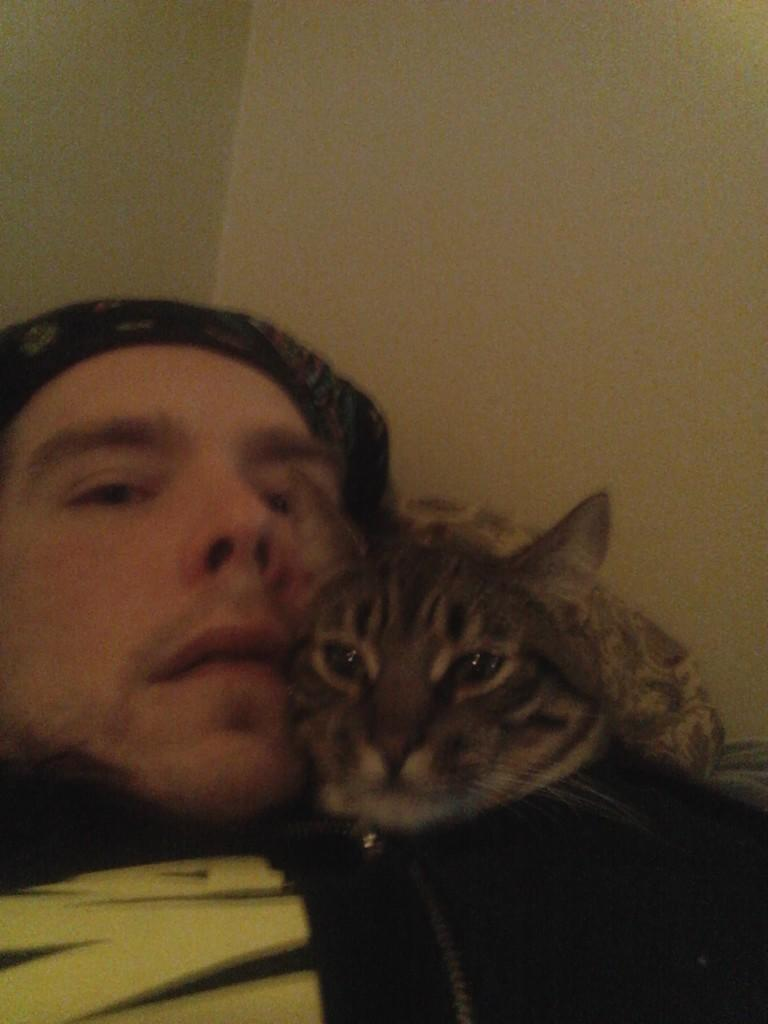Where was the image taken? The image was taken inside a room. What is the man in the image doing? The man is lying in the image. What is the man wearing on his head? The man is wearing a cap. What animal can be seen on top of the man? There is a cat on top of the man. What religious symbol can be seen hanging on the wall in the image? There is no religious symbol visible in the image. How does the sack contribute to the scene in the image? There is no sack present in the image. 